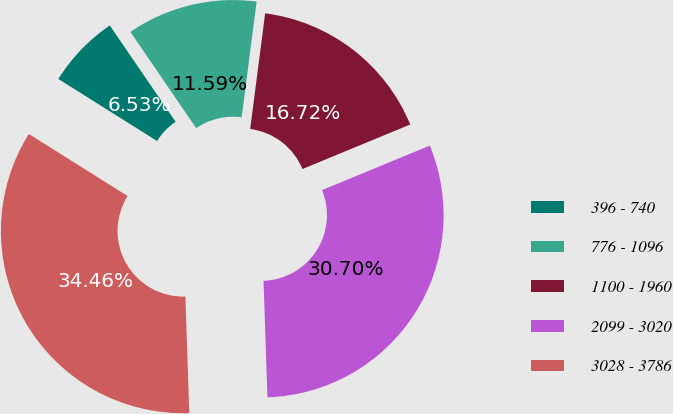Convert chart to OTSL. <chart><loc_0><loc_0><loc_500><loc_500><pie_chart><fcel>396 - 740<fcel>776 - 1096<fcel>1100 - 1960<fcel>2099 - 3020<fcel>3028 - 3786<nl><fcel>6.53%<fcel>11.59%<fcel>16.72%<fcel>30.7%<fcel>34.46%<nl></chart> 